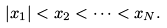Convert formula to latex. <formula><loc_0><loc_0><loc_500><loc_500>| x _ { 1 } | < x _ { 2 } < \dots < x _ { N } .</formula> 